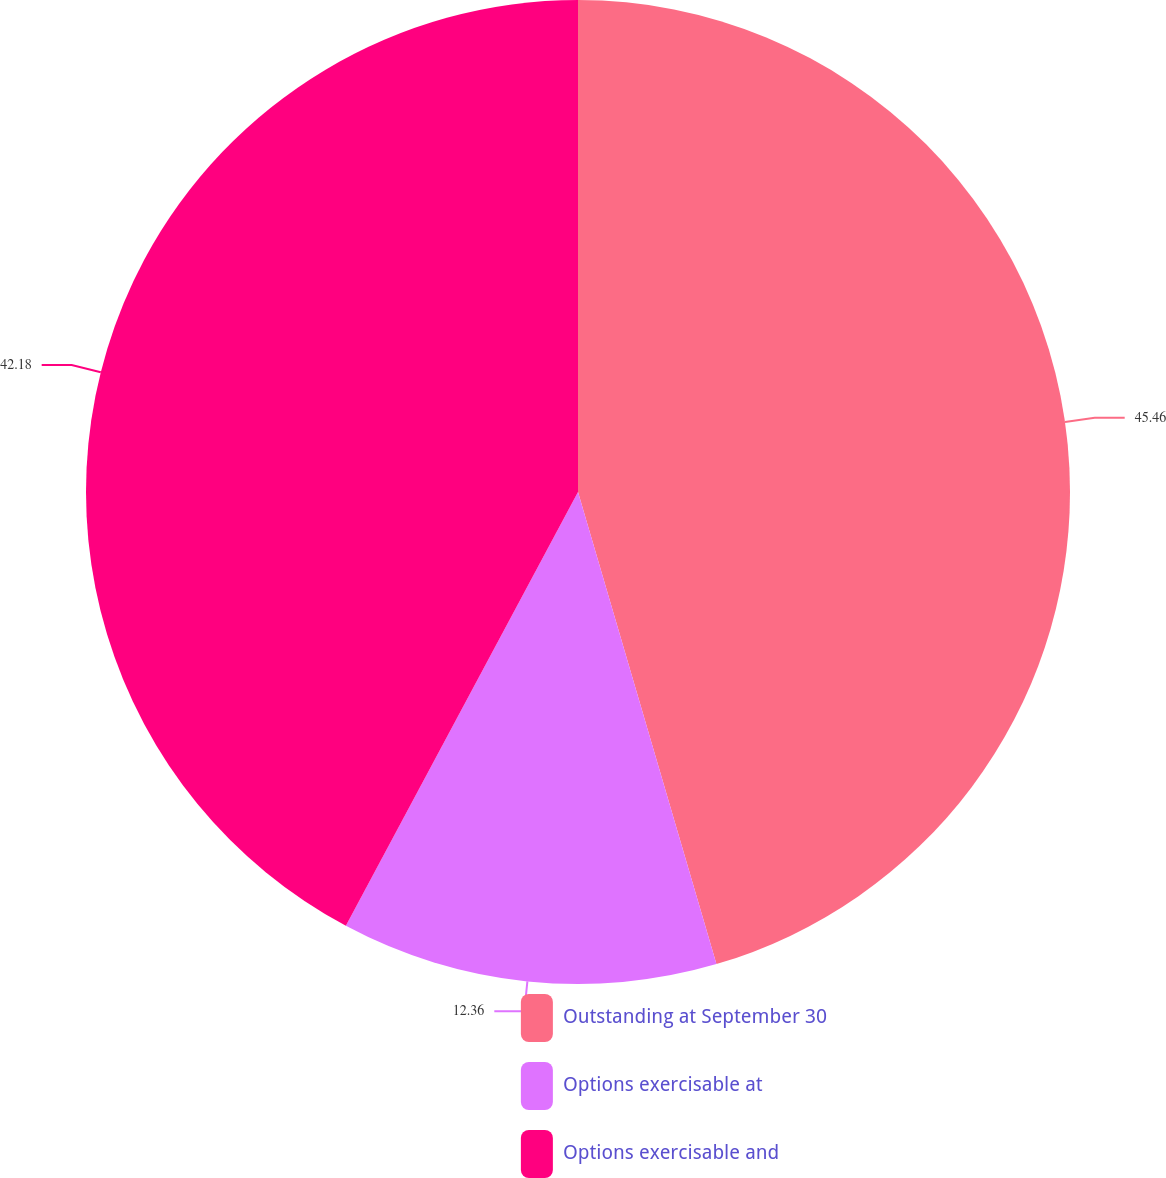Convert chart to OTSL. <chart><loc_0><loc_0><loc_500><loc_500><pie_chart><fcel>Outstanding at September 30<fcel>Options exercisable at<fcel>Options exercisable and<nl><fcel>45.46%<fcel>12.36%<fcel>42.18%<nl></chart> 